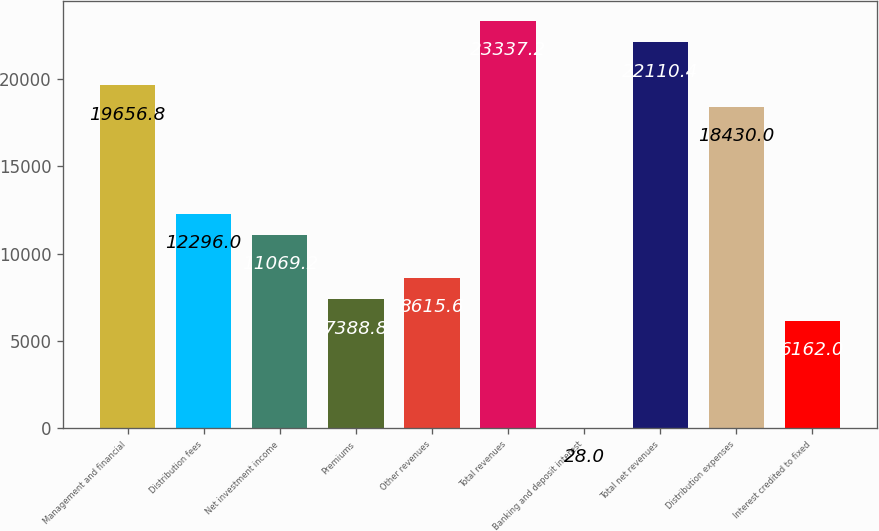Convert chart. <chart><loc_0><loc_0><loc_500><loc_500><bar_chart><fcel>Management and financial<fcel>Distribution fees<fcel>Net investment income<fcel>Premiums<fcel>Other revenues<fcel>Total revenues<fcel>Banking and deposit interest<fcel>Total net revenues<fcel>Distribution expenses<fcel>Interest credited to fixed<nl><fcel>19656.8<fcel>12296<fcel>11069.2<fcel>7388.8<fcel>8615.6<fcel>23337.2<fcel>28<fcel>22110.4<fcel>18430<fcel>6162<nl></chart> 